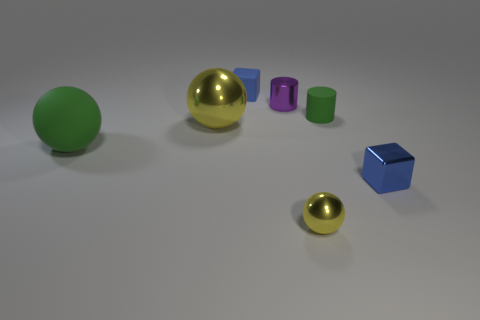Is the number of tiny green matte things less than the number of green rubber objects?
Ensure brevity in your answer.  Yes. Is there a small thing of the same color as the matte sphere?
Provide a short and direct response. Yes. The rubber object that is both behind the rubber sphere and left of the purple object has what shape?
Your answer should be compact. Cube. What is the shape of the small blue thing in front of the blue object behind the green sphere?
Keep it short and to the point. Cube. Do the small blue metal thing and the small blue rubber object have the same shape?
Ensure brevity in your answer.  Yes. There is a big sphere that is the same color as the tiny metallic ball; what is it made of?
Provide a short and direct response. Metal. Does the large shiny sphere have the same color as the small metal ball?
Your answer should be compact. Yes. There is a tiny rubber thing that is to the right of the small thing in front of the tiny shiny cube; what number of things are in front of it?
Offer a terse response. 4. The big green thing that is the same material as the green cylinder is what shape?
Your response must be concise. Sphere. What material is the blue cube in front of the tiny cylinder that is behind the tiny cylinder on the right side of the tiny purple cylinder made of?
Keep it short and to the point. Metal. 